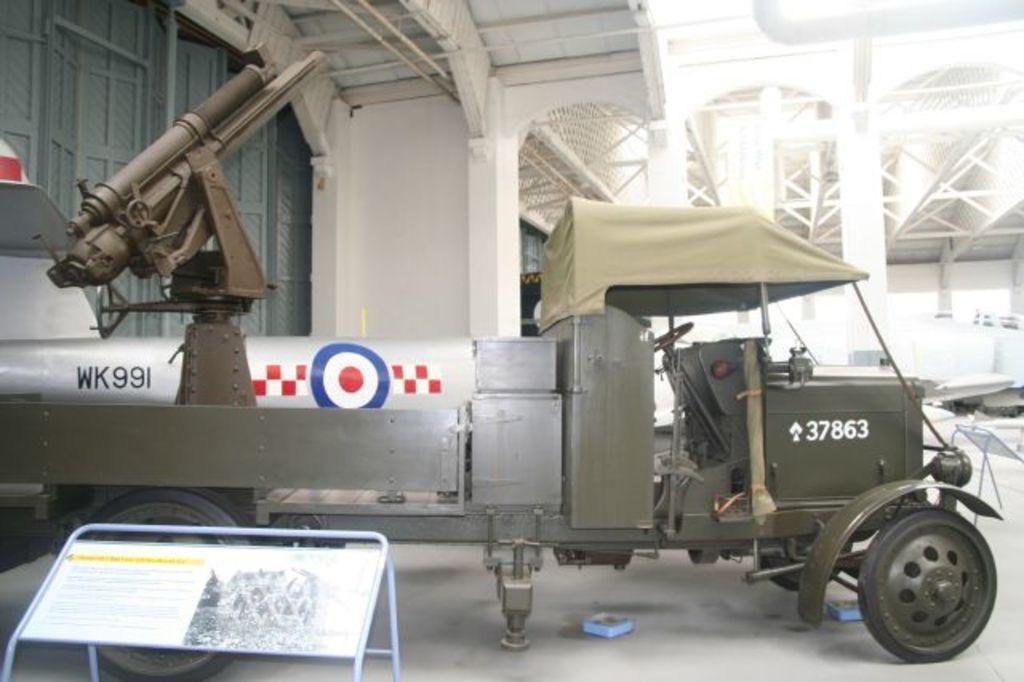Describe this image in one or two sentences. In this image I can see a white colour board on the left side and on it I can see something is written. Behind it I can see a vehicle, few doors and on the left side of this image I can see something is written. I can also see few blue colour thing on the ground. 